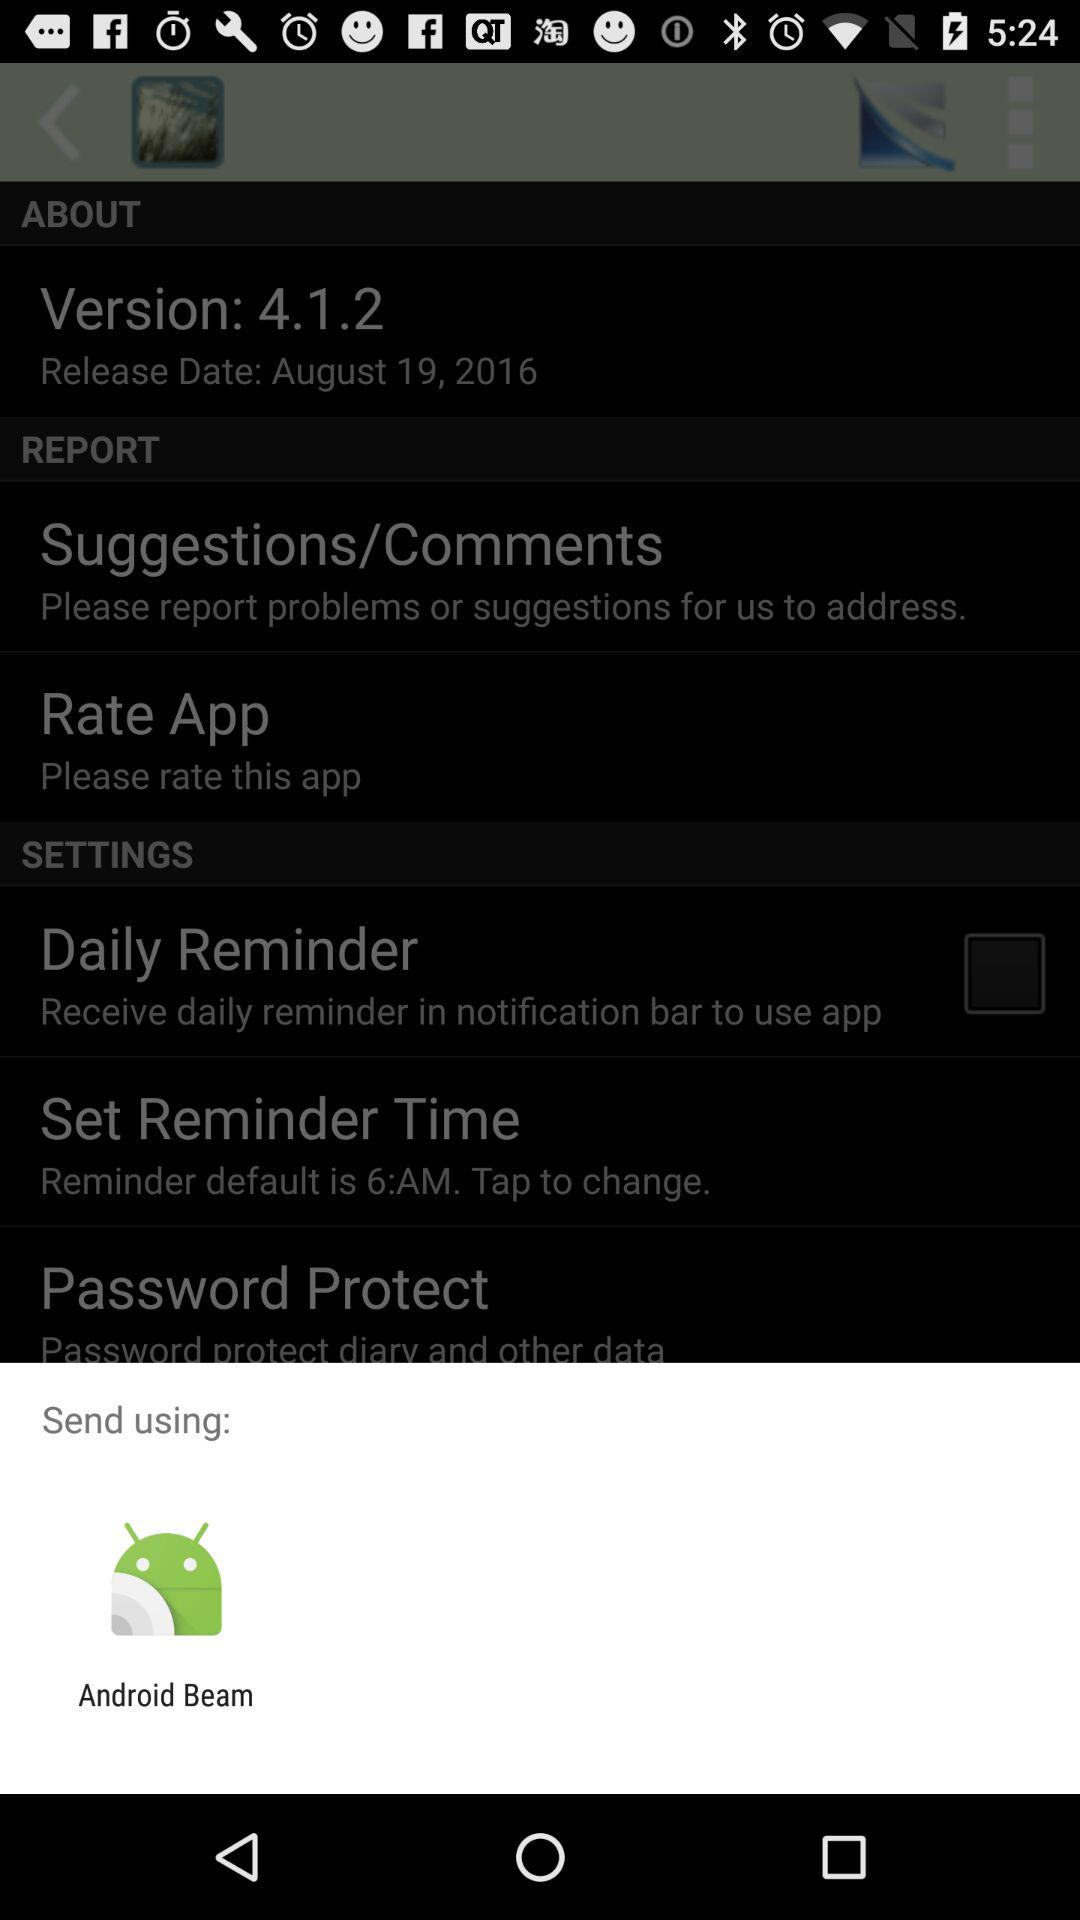What application can be used to send the data? The application that can be used to send the data is "Android Beam". 